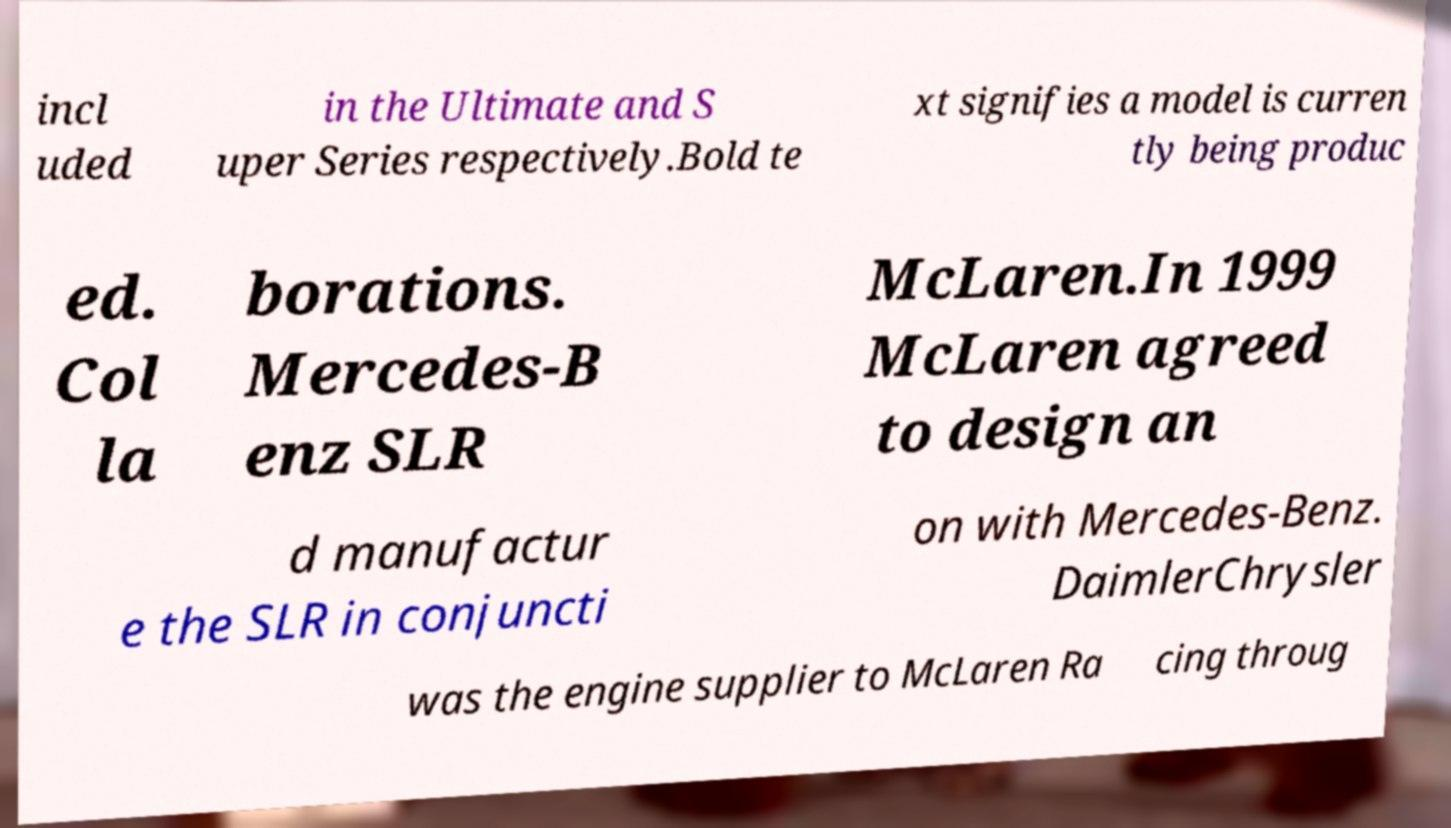Could you extract and type out the text from this image? incl uded in the Ultimate and S uper Series respectively.Bold te xt signifies a model is curren tly being produc ed. Col la borations. Mercedes-B enz SLR McLaren.In 1999 McLaren agreed to design an d manufactur e the SLR in conjuncti on with Mercedes-Benz. DaimlerChrysler was the engine supplier to McLaren Ra cing throug 